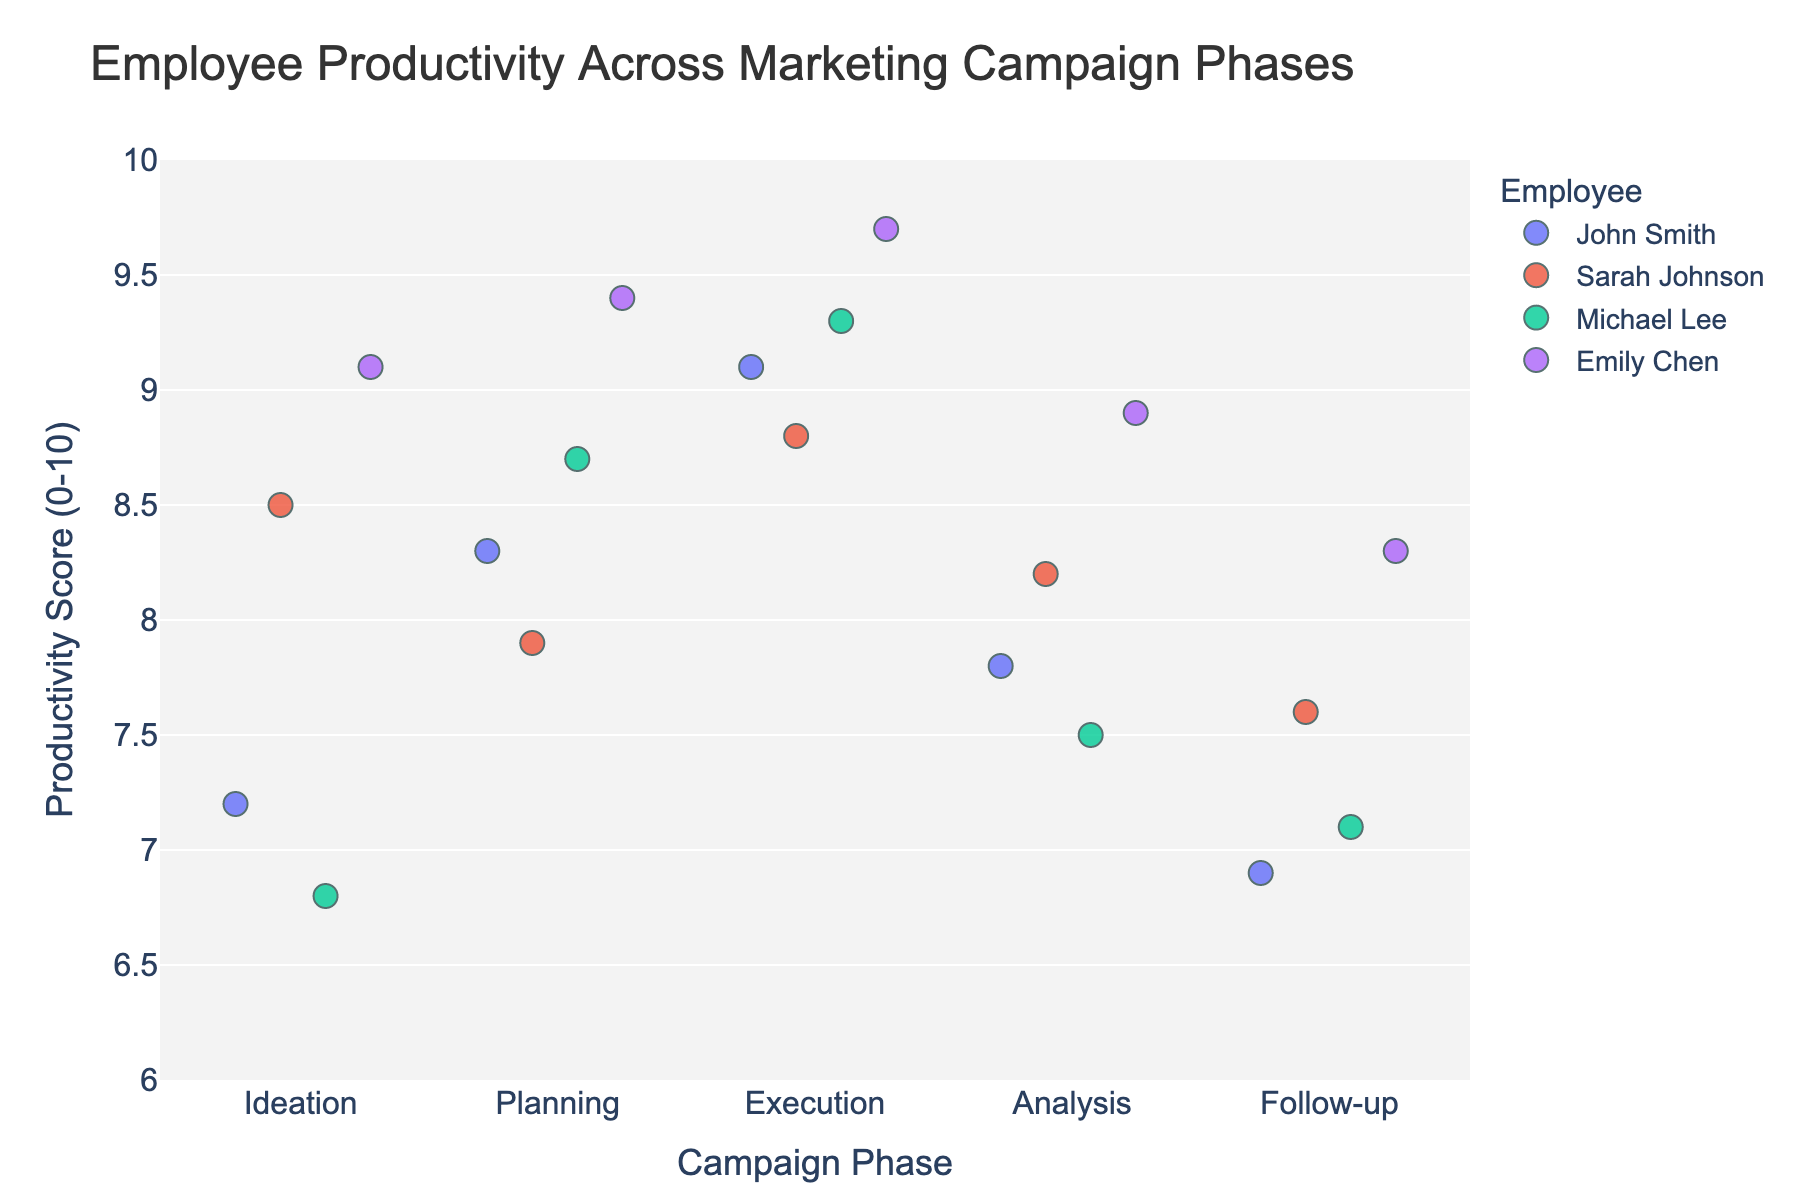What's the title of the figure? The title of the figure is usually displayed prominently at the top. By looking at the top center of the figure, we can see the title.
Answer: Employee Productivity Across Marketing Campaign Phases What are the axes labels? Axes labels are found along the x-axis and y-axis. The x-axis label indicates the different “Campaign Phase” categories, and the y-axis label shows the "Productivity Score (0-10)."
Answer: Campaign Phase (x-axis), Productivity Score (0-10) (y-axis) How does Sarah Johnson's productivity vary across the campaign phases? To determine Sarah Johnson's productivity across phases, locate the points corresponding to her name and track their positions on the y-axis across different phases on the x-axis. In Ideation, she's at approximately 8.5; in Planning, around 7.9; in Execution, approximately 8.8; in Analysis, around 8.2; and in Follow-up, she's at about 7.6.
Answer: Decreases from Ideation to Planning, increases in Execution, slight decrease in Analysis, and further decreases in Follow-up Which employee had the highest productivity score in the Execution phase? Identify the Execution phase on the x-axis and locate the highest data point within this category on the y-axis. Check the color/legend to see it corresponds to Emily Chen, who has a score around 9.7.
Answer: Emily Chen What is the general trend in John Smith's productivity throughout the campaign phases? By following John Smith's data points across phases, we see he starts close to 7.2 in Ideation, increases to about 8.3 in Planning, peaks at around 9.1 in Execution, drops to about 7.8 in Analysis, and then falls further to about 6.9 in Follow-up.
Answer: Increases during Initial Phases, Peaks in Execution, then Declines Calculate the average productivity score for Michael Lee across all phases. Add Michael Lee's scores for each phase and divide by the number of phases. His scores are: 6.8 (Ideation) + 8.7 (Planning) + 9.3 (Execution) + 7.5 (Analysis) + 7.1 (Follow-up). The sum is 39.4, and there are 5 phases, so the average is 39.4/5.
Answer: 7.88 Comparing Planning and Execution phases, which phase shows greater average productivity among all employees? Calculate the average productivity for each phase. For Planning: (8.3 + 7.9 + 8.7 + 9.4)/4 = 8.575. For Execution: (9.1 + 8.8 + 9.3 + 9.7)/4 = 9.225. Comparing the two, Execution has a higher average.
Answer: Execution phase Which campaign phase shows the least variability in productivity scores? Variability in scores can be assessed by visual clustering. The Execution phase shows the least spread, with all scores being relatively close (between about 8.8 and 9.7), indicating low variability.
Answer: Execution Is there a campaign phase where the productivity scores of all employees are above 8? Check each phase's data points against the value of 8. Ideation, Analysis, and Follow-up have points below 8. Both Planning and Execution phases have all points above 8.
Answer: Planning and Execution 